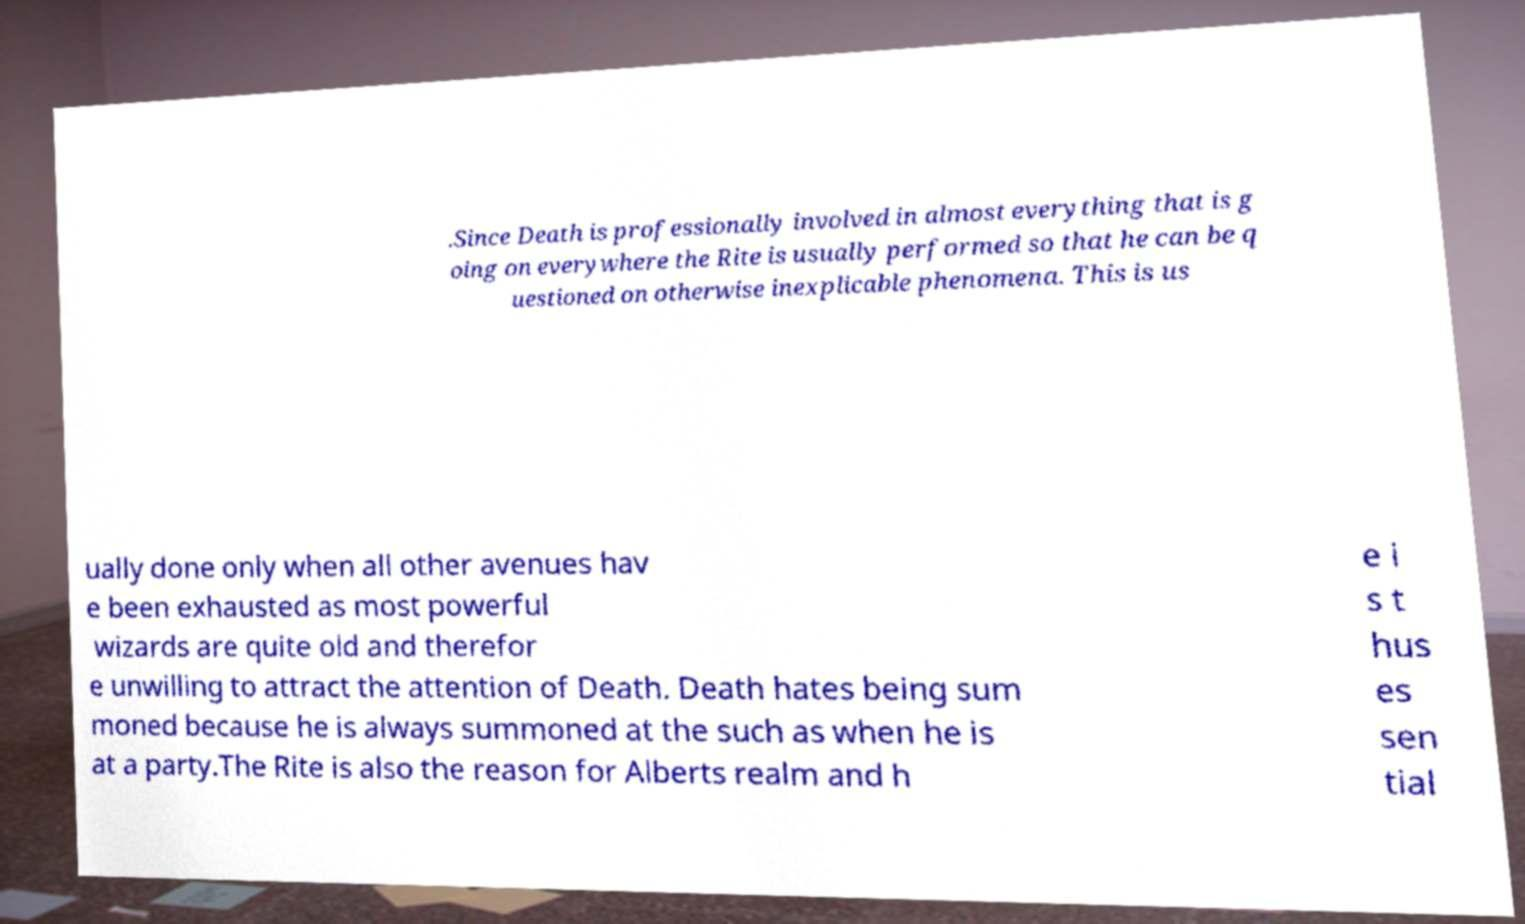Please read and relay the text visible in this image. What does it say? .Since Death is professionally involved in almost everything that is g oing on everywhere the Rite is usually performed so that he can be q uestioned on otherwise inexplicable phenomena. This is us ually done only when all other avenues hav e been exhausted as most powerful wizards are quite old and therefor e unwilling to attract the attention of Death. Death hates being sum moned because he is always summoned at the such as when he is at a party.The Rite is also the reason for Alberts realm and h e i s t hus es sen tial 